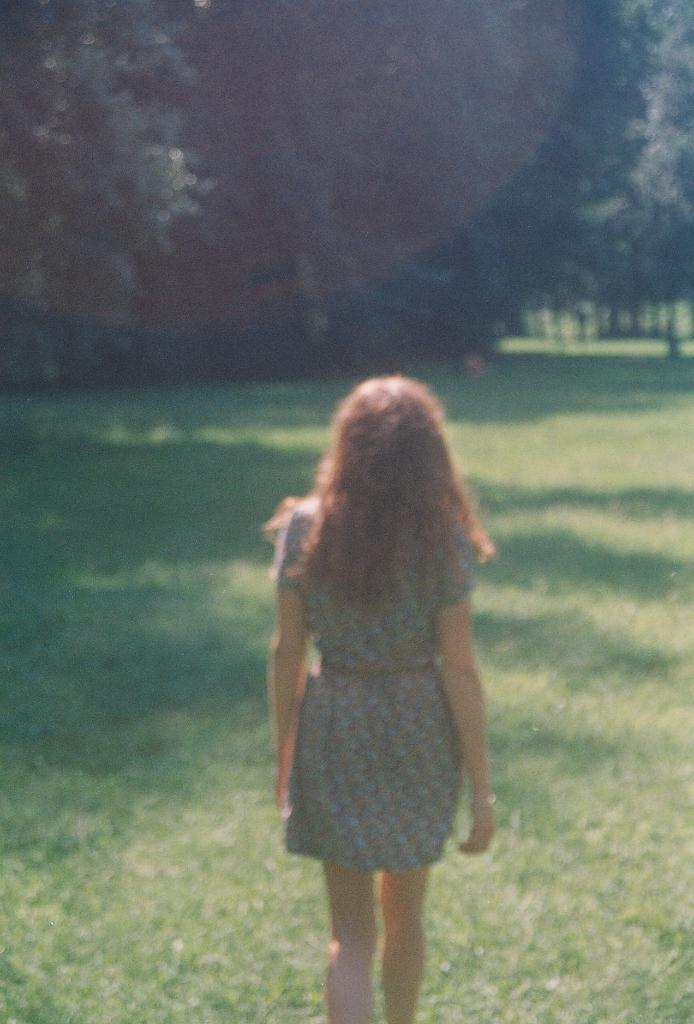Who is the main subject in the image? There is a woman in the image. What is the woman doing in the image? The woman is standing on the ground. Which direction is the woman facing? The woman is facing backwards. What can be seen in the background of the image? There are trees visible at the top of the image. What type of shoe is the woman wearing on her left foot in the image? There is no information about the woman's shoes in the image, so it cannot be determined what type of shoe she is wearing on her left foot. 